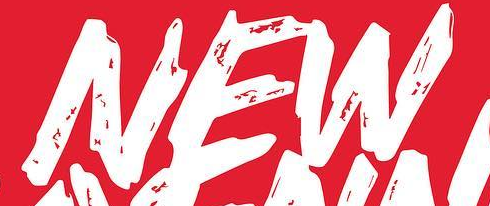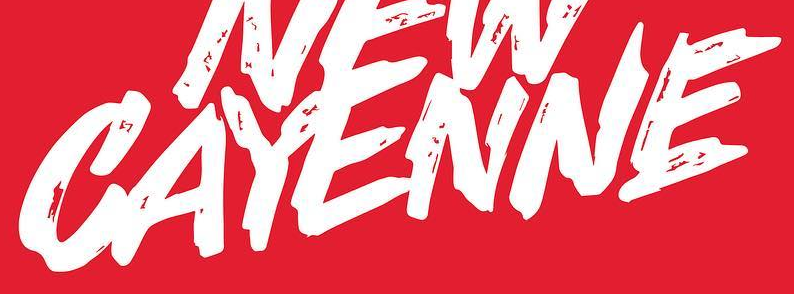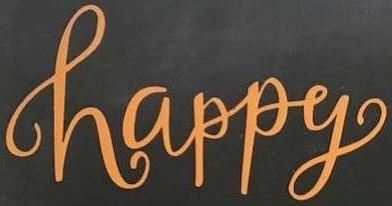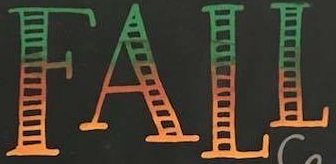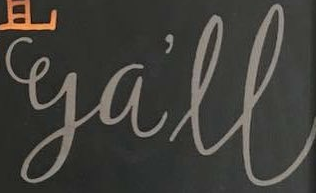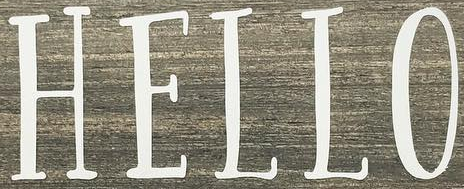What words can you see in these images in sequence, separated by a semicolon? NEW; CAYENNE; happy; FALL; ga'll; HELLO 